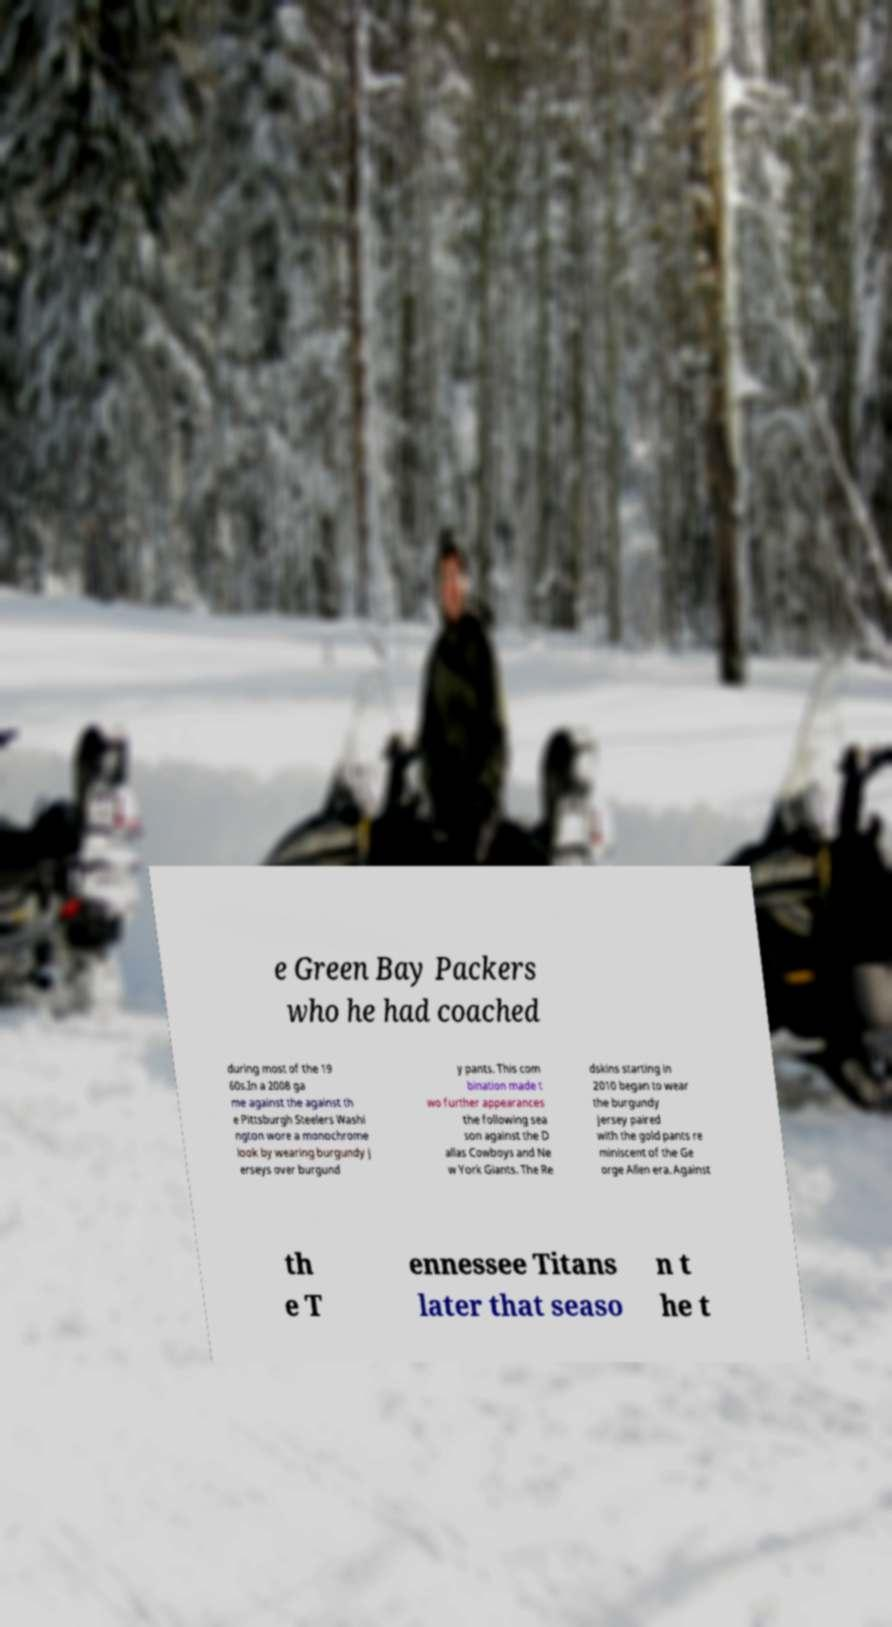I need the written content from this picture converted into text. Can you do that? e Green Bay Packers who he had coached during most of the 19 60s.In a 2008 ga me against the against th e Pittsburgh Steelers Washi ngton wore a monochrome look by wearing burgundy j erseys over burgund y pants. This com bination made t wo further appearances the following sea son against the D allas Cowboys and Ne w York Giants. The Re dskins starting in 2010 began to wear the burgundy jersey paired with the gold pants re miniscent of the Ge orge Allen era. Against th e T ennessee Titans later that seaso n t he t 